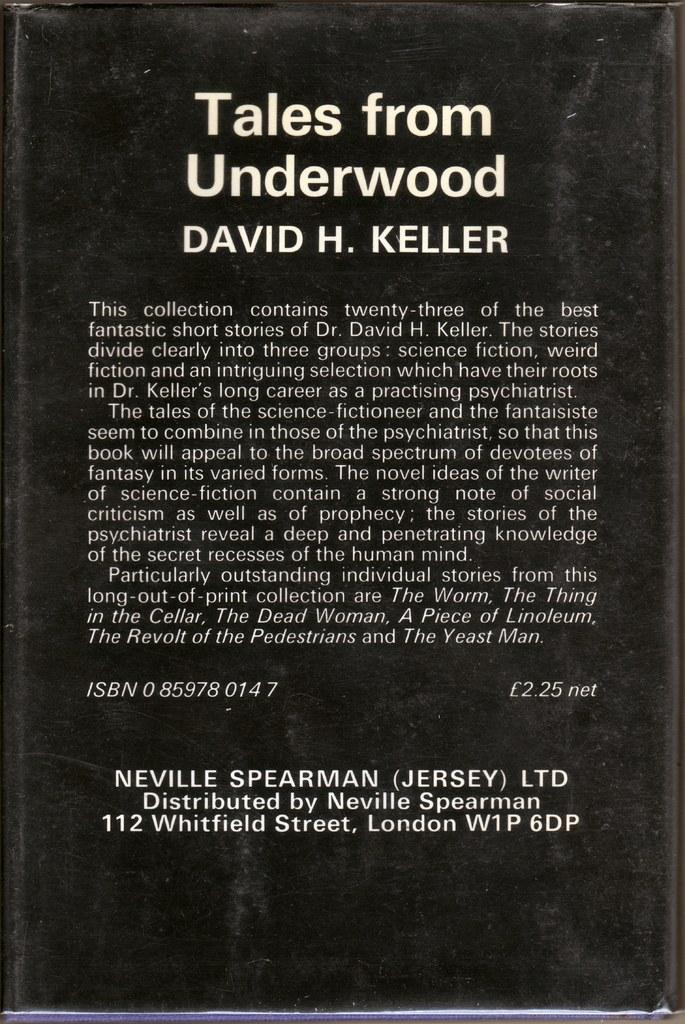<image>
Share a concise interpretation of the image provided. A book called Tales from Underwood by David H. Keller. 